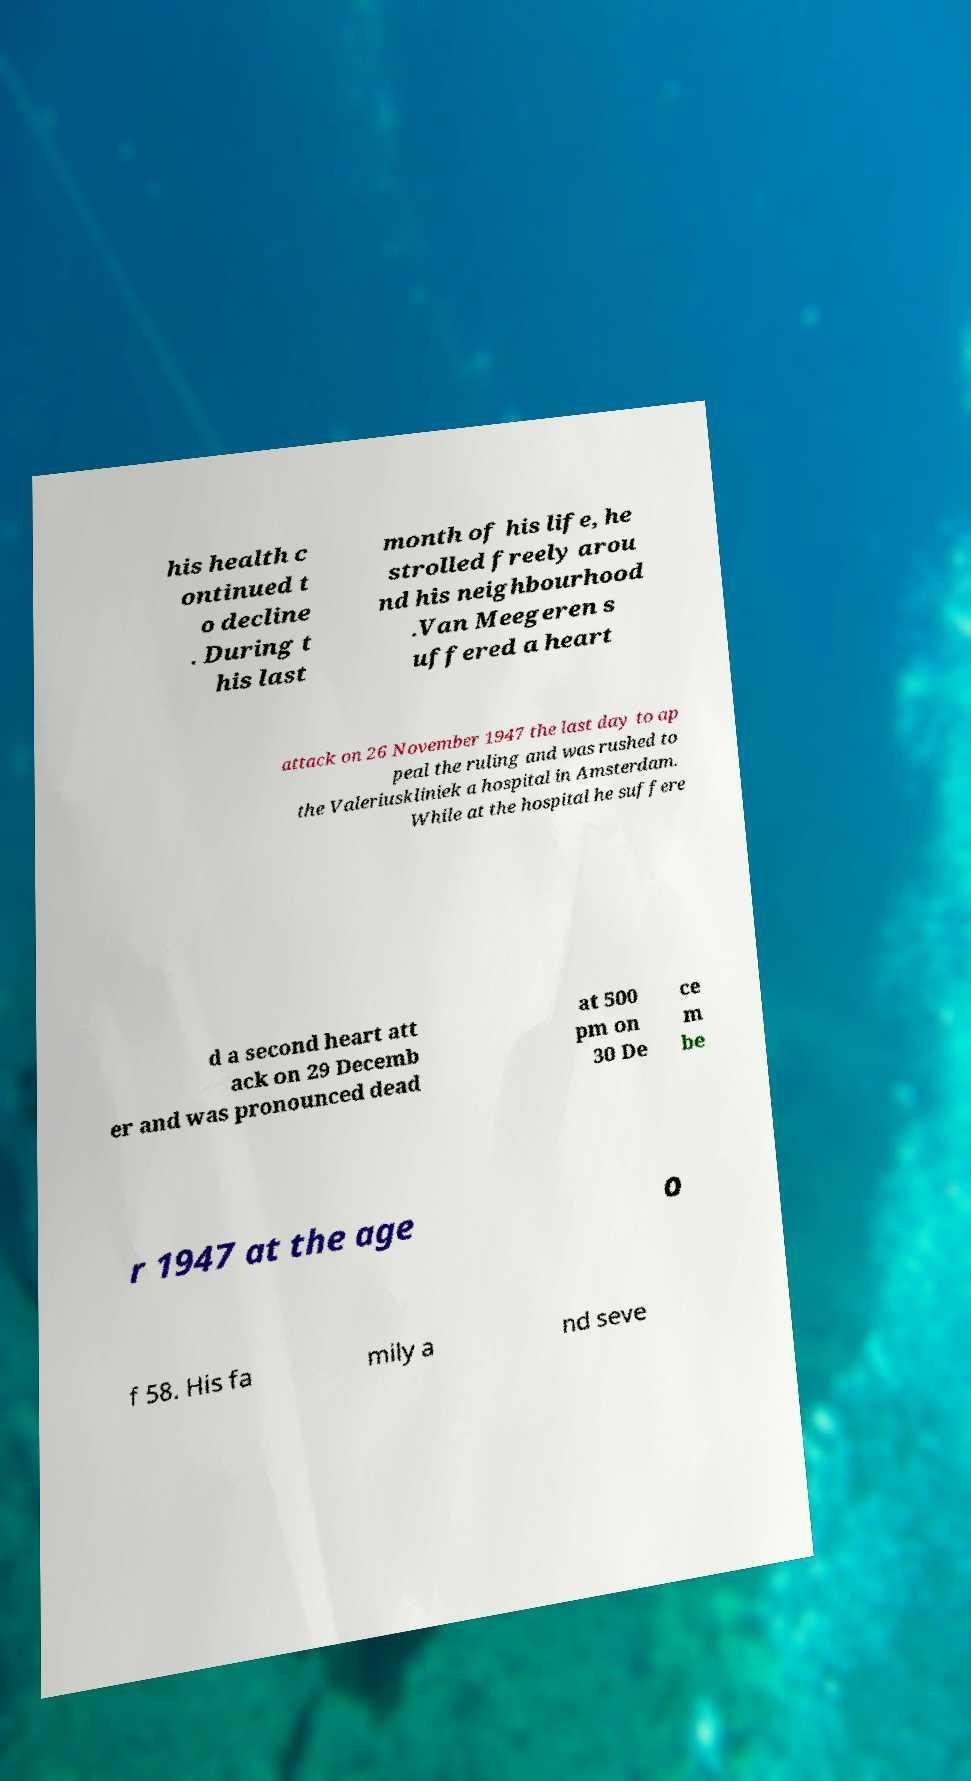Can you read and provide the text displayed in the image?This photo seems to have some interesting text. Can you extract and type it out for me? his health c ontinued t o decline . During t his last month of his life, he strolled freely arou nd his neighbourhood .Van Meegeren s uffered a heart attack on 26 November 1947 the last day to ap peal the ruling and was rushed to the Valeriuskliniek a hospital in Amsterdam. While at the hospital he suffere d a second heart att ack on 29 Decemb er and was pronounced dead at 500 pm on 30 De ce m be r 1947 at the age o f 58. His fa mily a nd seve 